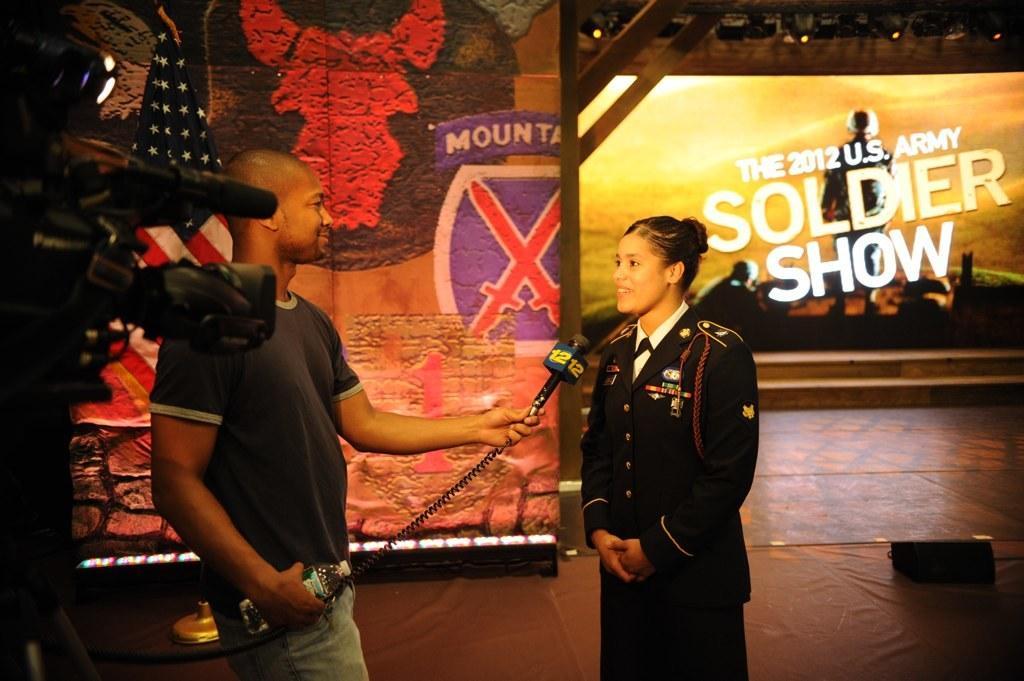Please provide a concise description of this image. In the image we can see a man and a woman wearing clothes and they are smiling. The man is holding a water bottle in one hand and on the other hand there is a microphone. Here we can see cable wire, video camera and the flag of the country. Here we can see the poster and the floor. 